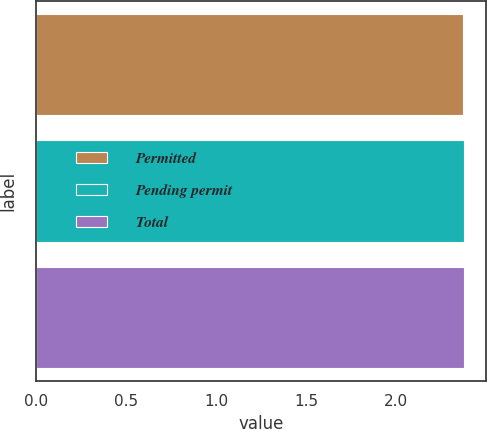Convert chart. <chart><loc_0><loc_0><loc_500><loc_500><bar_chart><fcel>Permitted<fcel>Pending permit<fcel>Total<nl><fcel>2.37<fcel>2.38<fcel>2.38<nl></chart> 